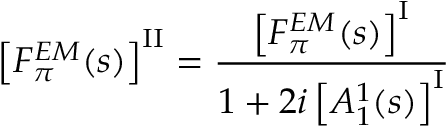<formula> <loc_0><loc_0><loc_500><loc_500>\left [ F _ { \pi } ^ { E M } ( s ) \right ] ^ { I I } = \frac { \left [ F _ { \pi } ^ { E M } ( s ) \right ] ^ { I } } { 1 + 2 i \left [ A _ { 1 } ^ { 1 } ( s ) \right ] ^ { I } }</formula> 